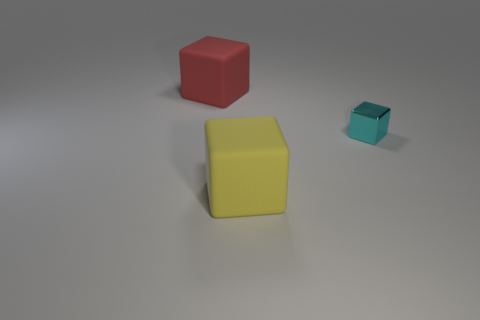Are there any other things that are made of the same material as the small object?
Ensure brevity in your answer.  No. What is the material of the cube that is the same size as the red matte object?
Give a very brief answer. Rubber. How many things are either tiny metal blocks or things to the right of the red object?
Your response must be concise. 2. There is a red rubber thing; is it the same size as the object in front of the small cyan thing?
Give a very brief answer. Yes. What number of balls are small metallic objects or large yellow rubber things?
Your response must be concise. 0. What number of objects are in front of the tiny metallic block and on the right side of the large yellow thing?
Keep it short and to the point. 0. How many other things are the same color as the tiny thing?
Your answer should be very brief. 0. The matte thing behind the big yellow rubber block has what shape?
Your answer should be compact. Cube. Is the material of the cyan object the same as the yellow thing?
Your response must be concise. No. Are there any other things that are the same size as the metal cube?
Give a very brief answer. No. 